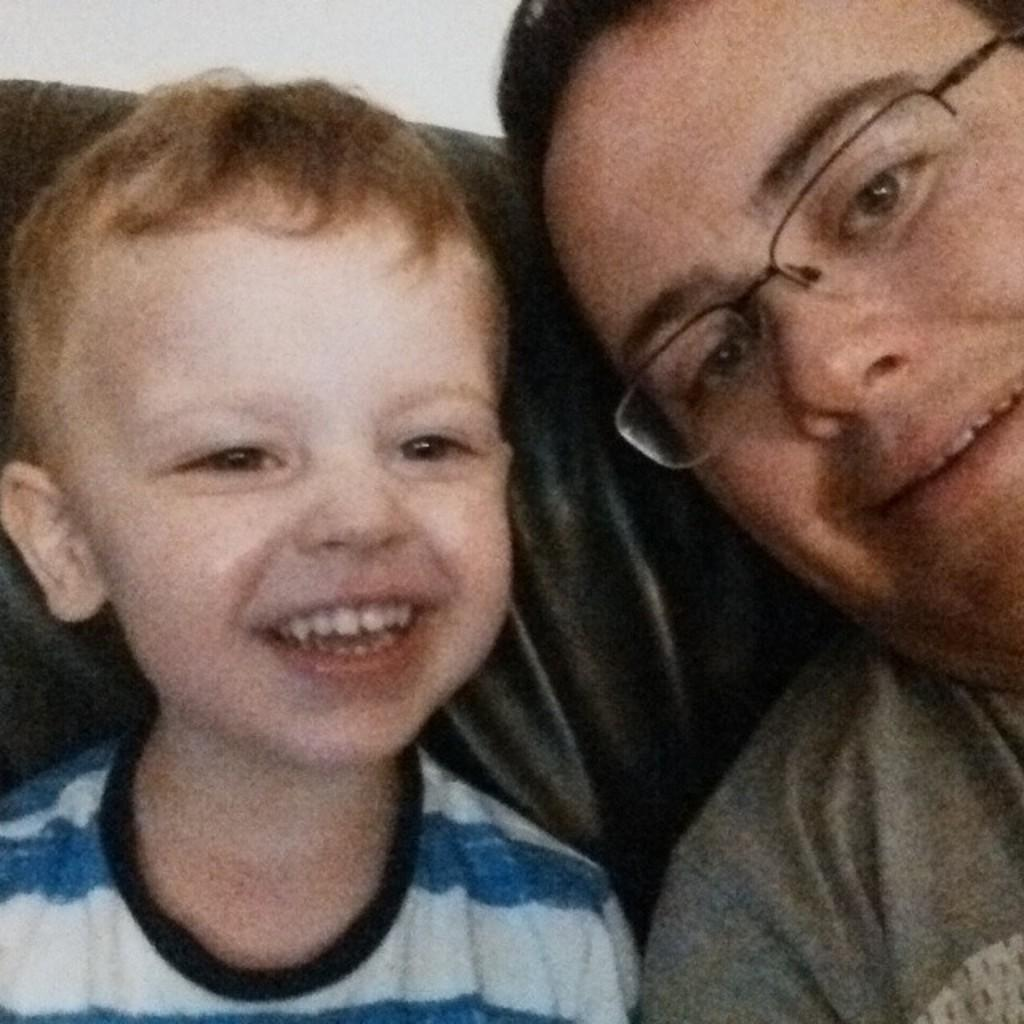What is the person in the image wearing? The person is wearing goggles. Who else is present in the image? There is a child in the image. What is the child doing in the image? The child is sitting on a sofa. What type of donkey can be seen in the image? There is no donkey present in the image. Is the scene taking place during the night in the image? The image does not provide information about the time of day, so it cannot be determined if it is night or not. 